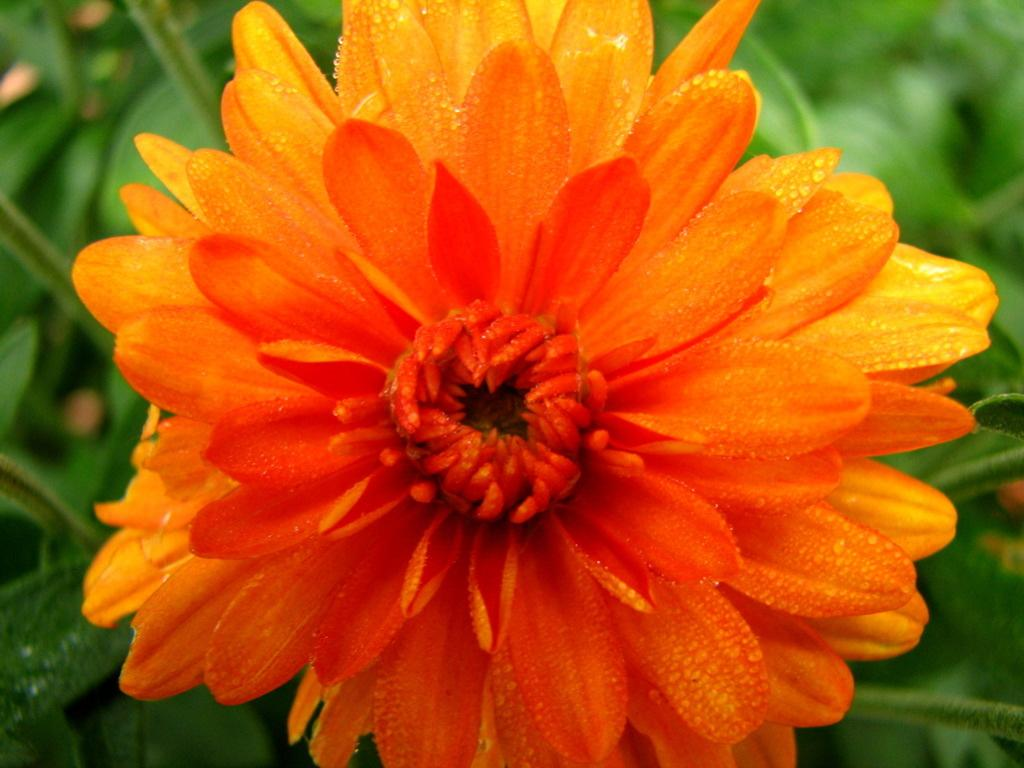What is the main subject of the picture? There is a flower in the picture. What can be seen in the background of the picture? There are leaves in the background of the picture. What type of stomach can be seen in the picture? There is no stomach present in the picture; it features a flower and leaves. How many times does the flower bite in the picture? Flowers do not bite, so this question cannot be answered. 